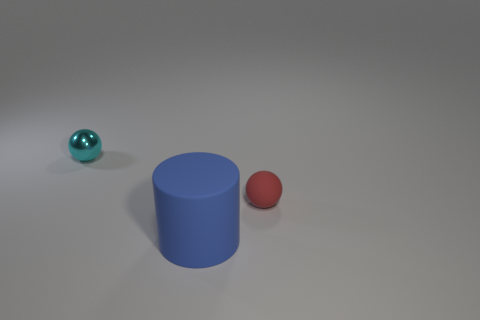Add 3 green shiny balls. How many objects exist? 6 Subtract all balls. How many objects are left? 1 Add 2 large rubber things. How many large rubber things are left? 3 Add 1 red matte things. How many red matte things exist? 2 Subtract 0 green blocks. How many objects are left? 3 Subtract all tiny red matte balls. Subtract all big cyan spheres. How many objects are left? 2 